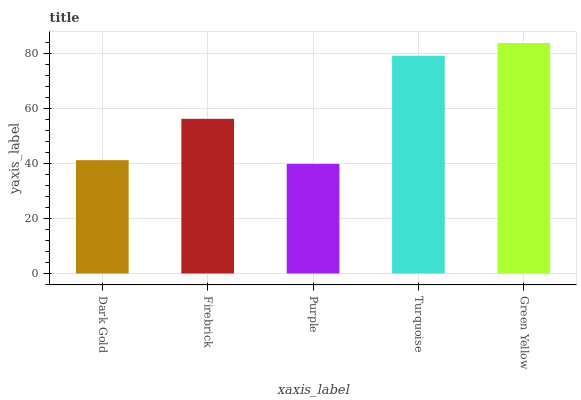Is Purple the minimum?
Answer yes or no. Yes. Is Green Yellow the maximum?
Answer yes or no. Yes. Is Firebrick the minimum?
Answer yes or no. No. Is Firebrick the maximum?
Answer yes or no. No. Is Firebrick greater than Dark Gold?
Answer yes or no. Yes. Is Dark Gold less than Firebrick?
Answer yes or no. Yes. Is Dark Gold greater than Firebrick?
Answer yes or no. No. Is Firebrick less than Dark Gold?
Answer yes or no. No. Is Firebrick the high median?
Answer yes or no. Yes. Is Firebrick the low median?
Answer yes or no. Yes. Is Purple the high median?
Answer yes or no. No. Is Turquoise the low median?
Answer yes or no. No. 